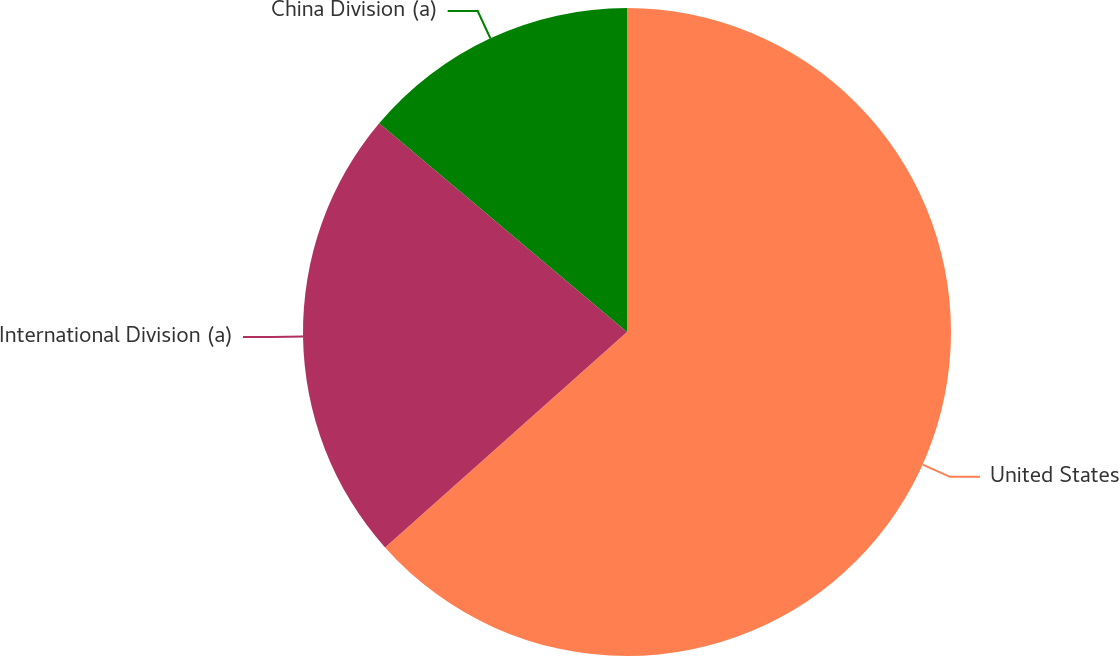Convert chart. <chart><loc_0><loc_0><loc_500><loc_500><pie_chart><fcel>United States<fcel>International Division (a)<fcel>China Division (a)<nl><fcel>63.42%<fcel>22.72%<fcel>13.86%<nl></chart> 